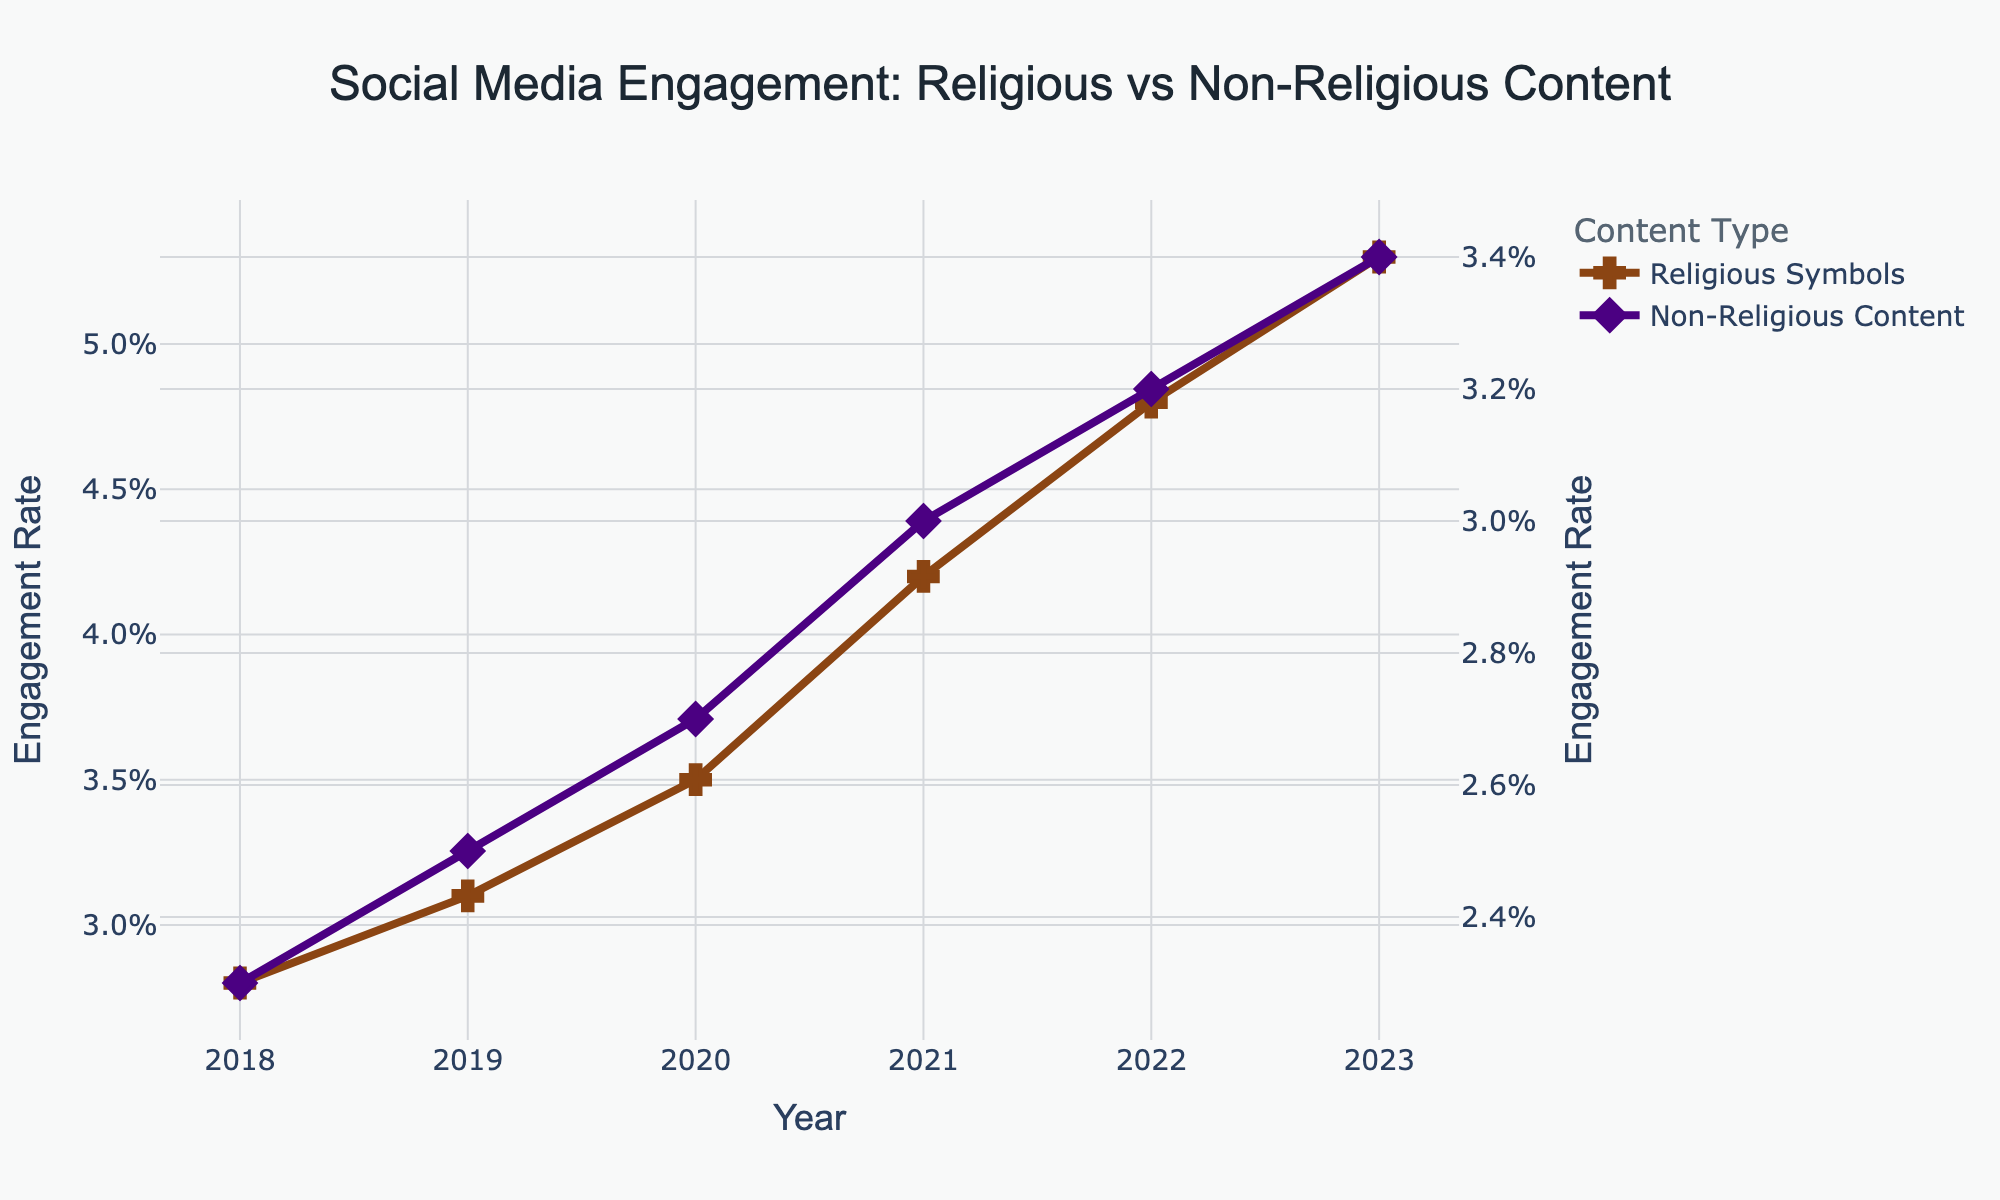What is the general trend in engagement rates for posts with religious symbols over the years? The graph shows a continuous increase in engagement rates for posts with religious symbols from 2018 to 2023. The line representing these posts moves upward consistently each year.
Answer: Increasing How much did the engagement rate for religious symbols increase from 2018 to 2023? The engagement rate for religious symbols in 2018 was 2.8%, and in 2023 it was 5.3%. The difference is calculated as 5.3% - 2.8% = 2.5%.
Answer: 2.5% By how much were the engagement rates of non-religious content lower than those of religious symbols in 2020? In 2020, the engagement rate for religious symbols was 3.5%, and for non-religious content, it was 2.7%. The difference is 3.5% - 2.7% = 0.8%.
Answer: 0.8% Compare the slopes of the lines for religious symbols and non-religious content. Which one has a steeper slope? The slope is the rate of increase in engagement rates. The engagement rate for religious symbols increases from 2.8% to 5.3% (2.5%) over five years, while for non-religious content it increases from 2.3% to 3.4% (1.1%) in the same period. Since 2.5% > 1.1%, the slope for religious symbols is steeper.
Answer: Religious Symbols What was the average engagement rate for non-religious content over the years? The engagement rates for non-religious content are: 2.3%, 2.5%, 2.7%, 3.0%, 3.2%, and 3.4%. Summing these gives 17.1%, and the average is 17.1% / 6 = 2.85%.
Answer: 2.85% In which year did engagement for religious symbols surpass 4%? By looking at the graph, we observe that the engagement rate for religious symbols surpassed 4% in 2021.
Answer: 2021 What is the difference in growth rate between religious symbols and non-religious content from 2018 to 2023? The growth for religious symbols from 2018 to 2023 is 5.3% - 2.8% = 2.5%. For non-religious content, it is 3.4% - 2.3% = 1.1%. The difference in growth rates is 2.5% - 1.1% = 1.4%.
Answer: 1.4% Between 2019 and 2022, which type of content saw a larger increase in engagement rates? For religious symbols, the rate increased from 3.1% to 4.8% (1.7%). For non-religious content, the rate increased from 2.5% to 3.2% (0.7%). Therefore, religious symbols saw a larger increase.
Answer: Religious Symbols 